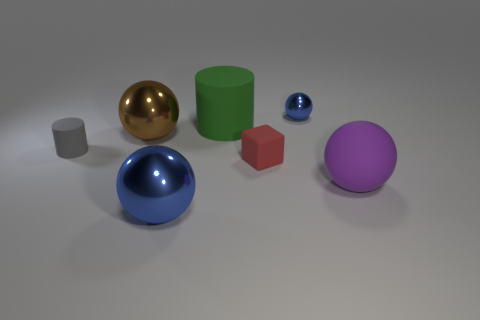There is a small object that is the same shape as the big green matte object; what is it made of?
Offer a terse response. Rubber. The blue shiny thing that is right of the large green rubber cylinder has what shape?
Ensure brevity in your answer.  Sphere. What color is the big rubber cylinder?
Your answer should be compact. Green. The small thing that is the same material as the big brown sphere is what shape?
Ensure brevity in your answer.  Sphere. Does the cylinder that is in front of the green cylinder have the same size as the big purple thing?
Make the answer very short. No. What number of objects are big objects behind the brown ball or matte cylinders behind the small gray cylinder?
Provide a succinct answer. 1. Is the color of the thing that is in front of the large rubber ball the same as the small cylinder?
Provide a succinct answer. No. How many shiny objects are either cyan cylinders or tiny red things?
Provide a succinct answer. 0. The big green rubber thing is what shape?
Give a very brief answer. Cylinder. Is there anything else that is made of the same material as the large blue ball?
Make the answer very short. Yes. 